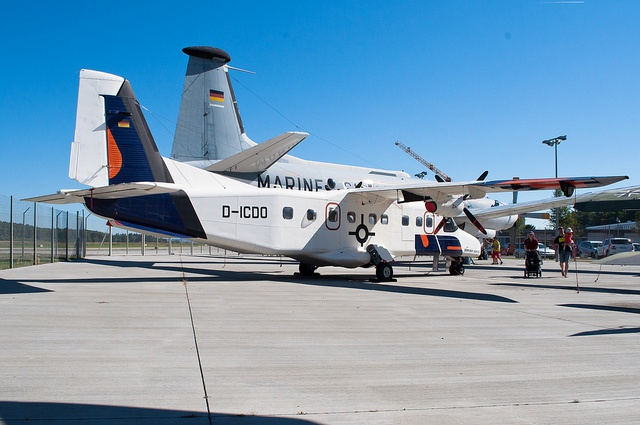Describe the objects in this image and their specific colors. I can see airplane in gray, lightgray, black, and darkgray tones, car in gray, black, blue, and navy tones, people in gray, black, maroon, and olive tones, car in gray, black, blue, and lightgray tones, and car in gray, navy, blue, and black tones in this image. 